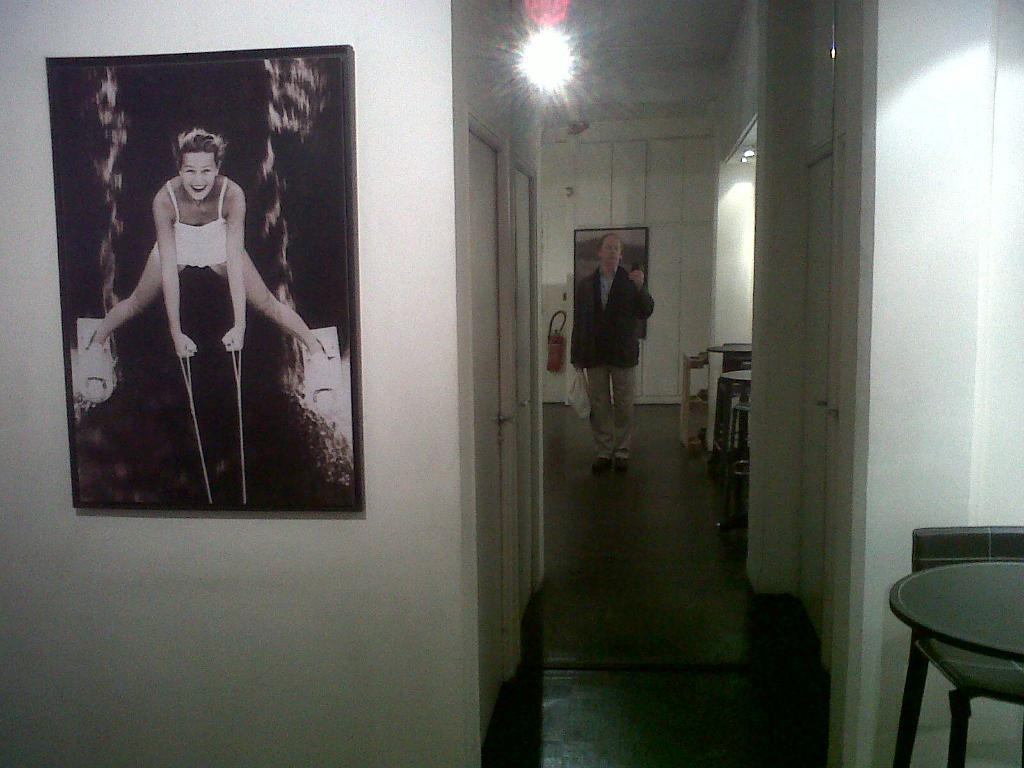Who is present in the image? There is a man in the image. What is on the left side of the image? There is a wall and doors on the left side of the image. What can be seen on the wall? There is a photo frame on the wall. What type of glove is the man wearing in the image? The man is not wearing a glove in the image. What is the man's tendency towards stitching in the image? There is no information about the man's tendency towards stitching in the image. 